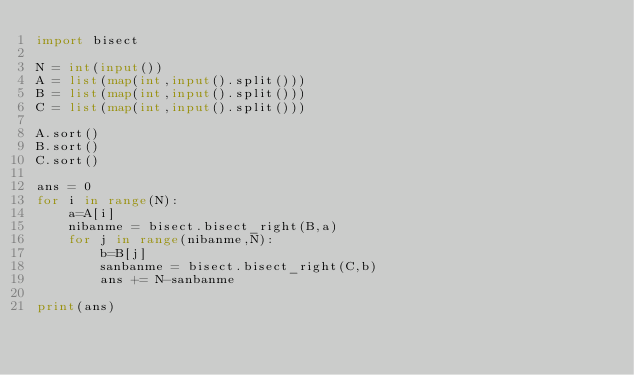Convert code to text. <code><loc_0><loc_0><loc_500><loc_500><_Python_>import bisect

N = int(input())
A = list(map(int,input().split()))
B = list(map(int,input().split()))
C = list(map(int,input().split()))

A.sort()
B.sort()
C.sort()

ans = 0
for i in range(N):
    a=A[i]
    nibanme = bisect.bisect_right(B,a)
    for j in range(nibanme,N):
        b=B[j]
        sanbanme = bisect.bisect_right(C,b)
        ans += N-sanbanme

print(ans)
</code> 